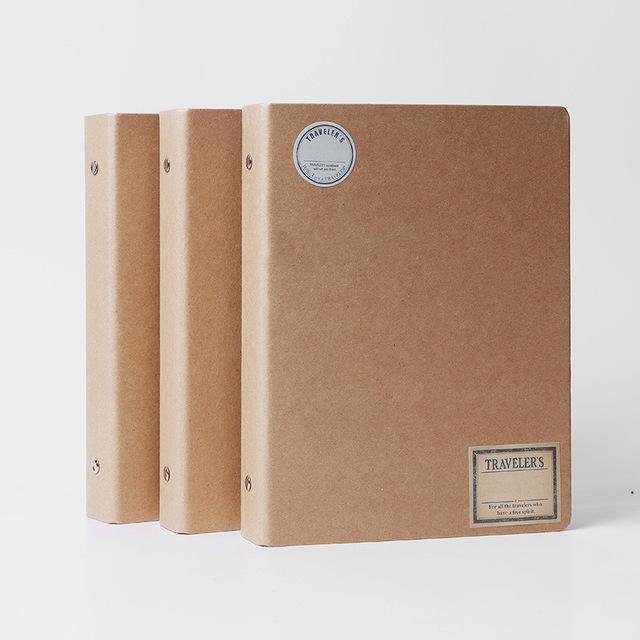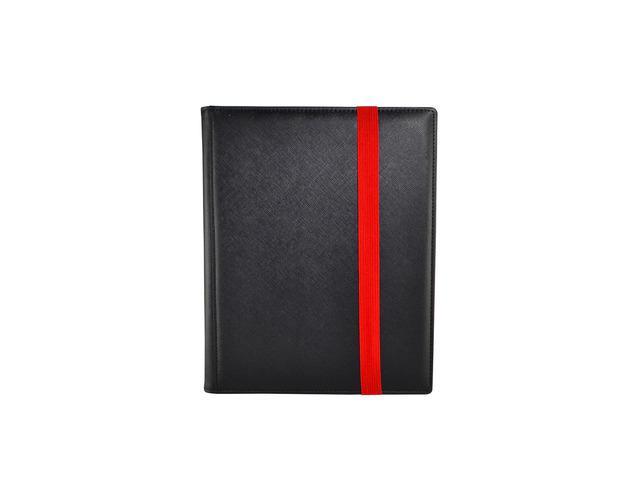The first image is the image on the left, the second image is the image on the right. Considering the images on both sides, is "A set of three tan notebooks is arranged in a standing position." valid? Answer yes or no. Yes. 